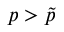Convert formula to latex. <formula><loc_0><loc_0><loc_500><loc_500>p > \tilde { p }</formula> 